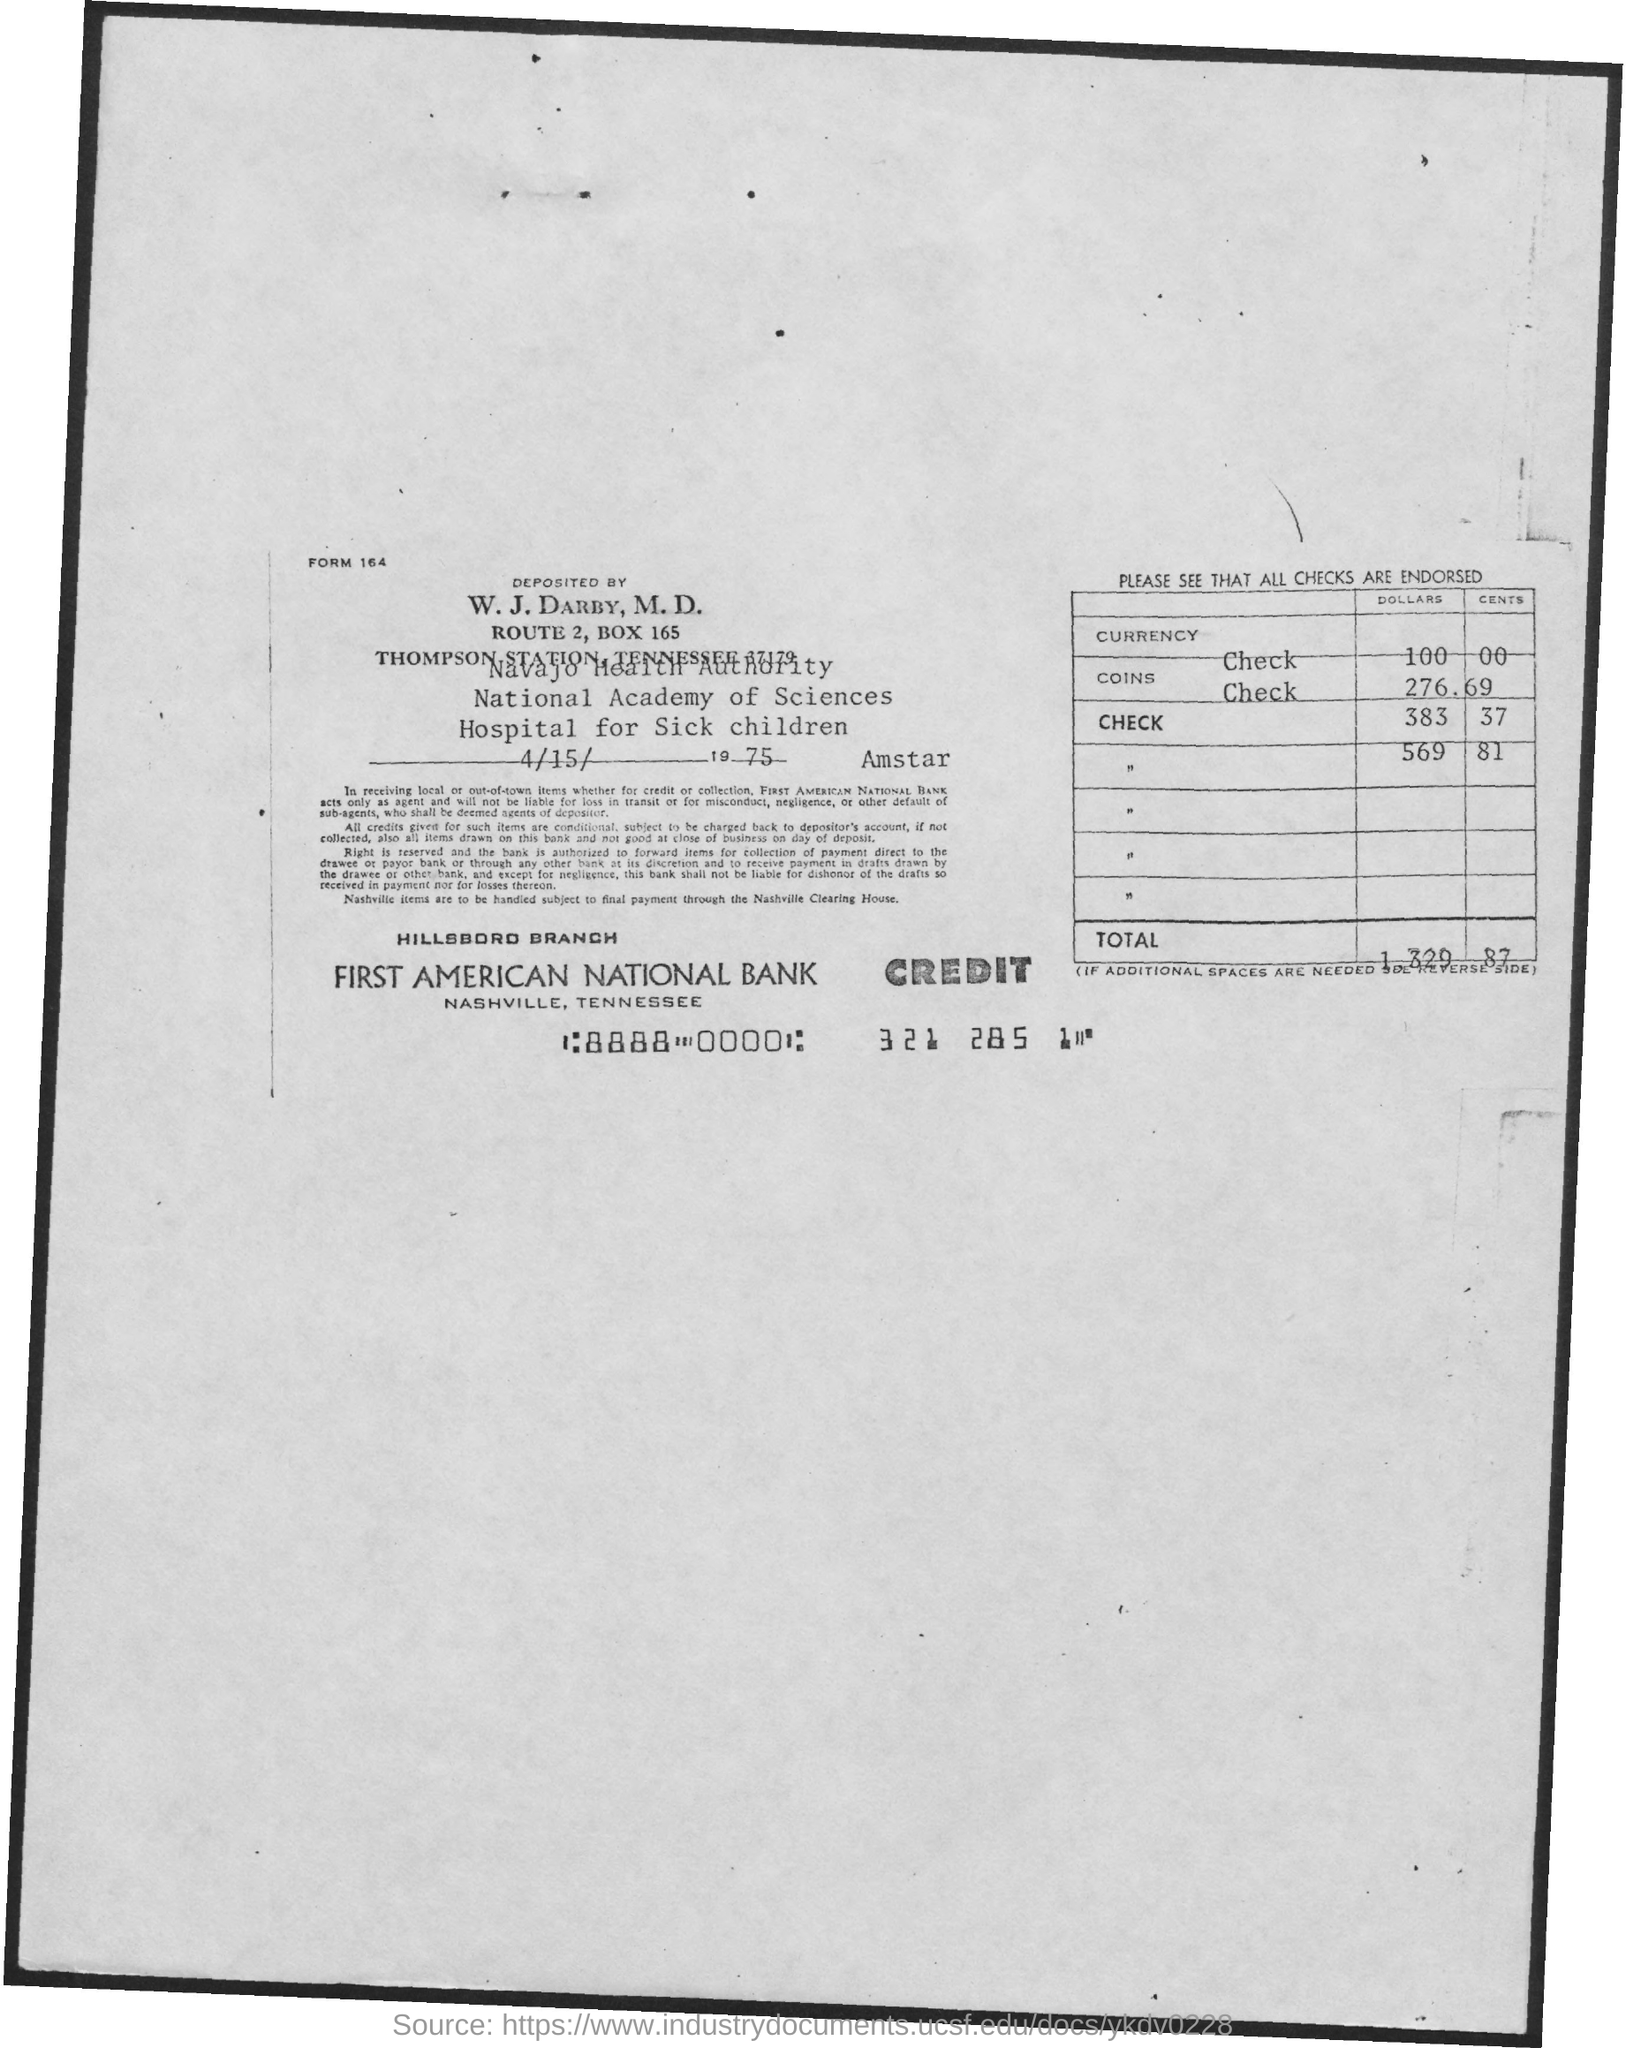What is the form no.?
Ensure brevity in your answer.  164. What is the date of deposit?
Make the answer very short. 4/15/1975. What is the total amount of deposit?
Your response must be concise. 1329.87. What is the name of the branch ?
Keep it short and to the point. Hillsbord Branch. What is the name of the bank?
Offer a terse response. First American National Bank. What is the address of first american national bank?
Provide a short and direct response. Nashville, Tennessee. 